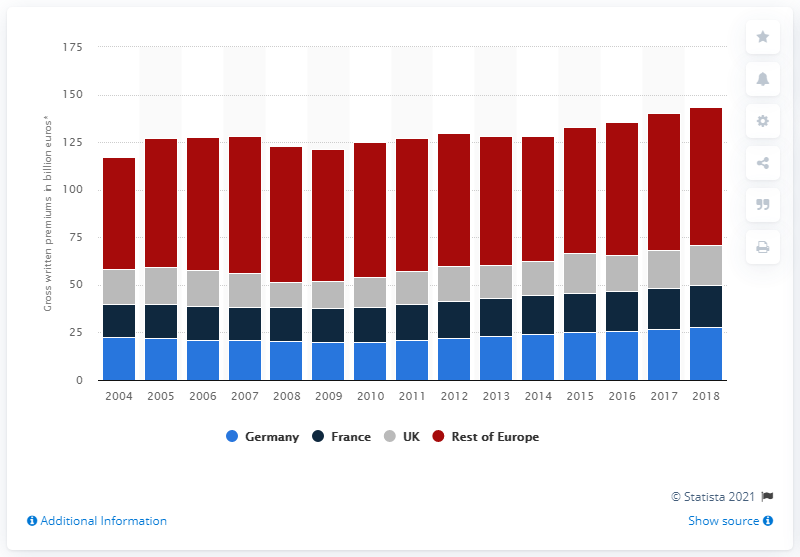Draw attention to some important aspects in this diagram. In 2018, Germany's gross written premium value was 27.92. 